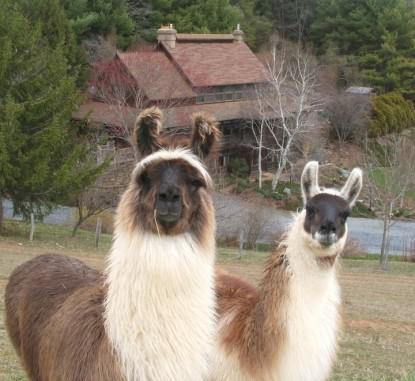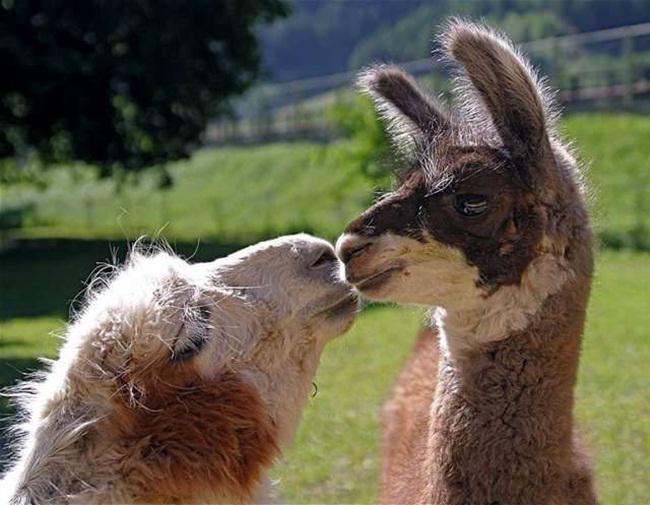The first image is the image on the left, the second image is the image on the right. Examine the images to the left and right. Is the description "Two llamas have brown ears." accurate? Answer yes or no. Yes. The first image is the image on the left, the second image is the image on the right. Examine the images to the left and right. Is the description "Each image features exactly two llamas in the foreground." accurate? Answer yes or no. Yes. 